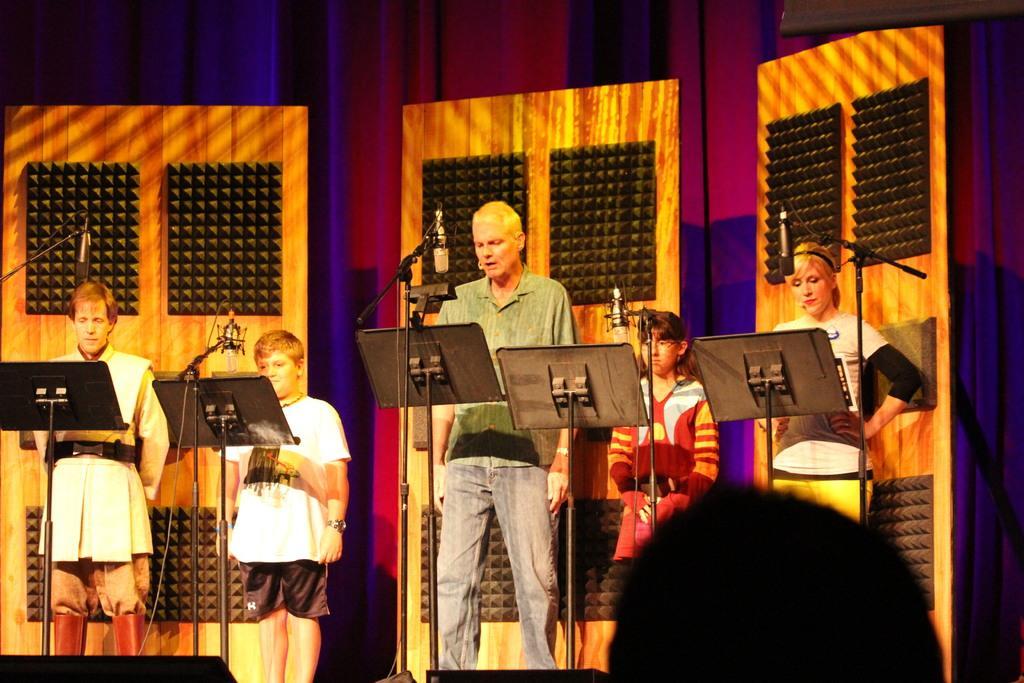Please provide a concise description of this image. In this image, we can see people standing on the stage and there are mics and stands. In the background, there are boards and we can see a curtain. At the bottom, there are some other objects and we can see a person. 